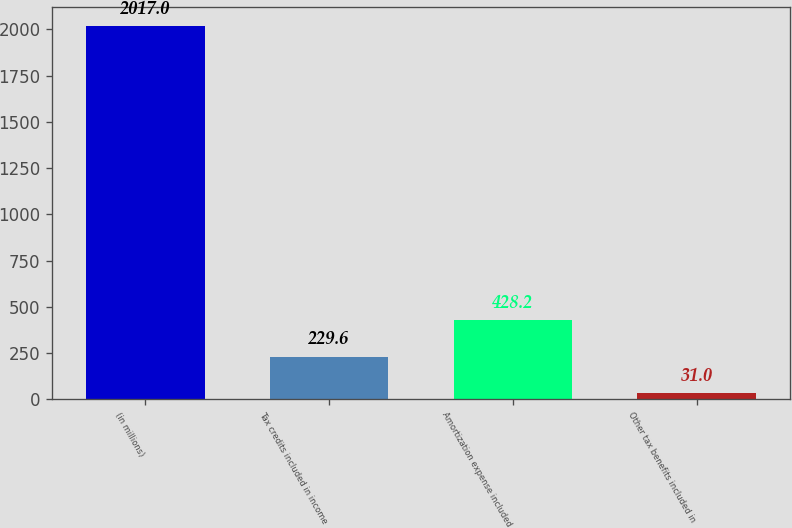<chart> <loc_0><loc_0><loc_500><loc_500><bar_chart><fcel>(in millions)<fcel>Tax credits included in income<fcel>Amortization expense included<fcel>Other tax benefits included in<nl><fcel>2017<fcel>229.6<fcel>428.2<fcel>31<nl></chart> 